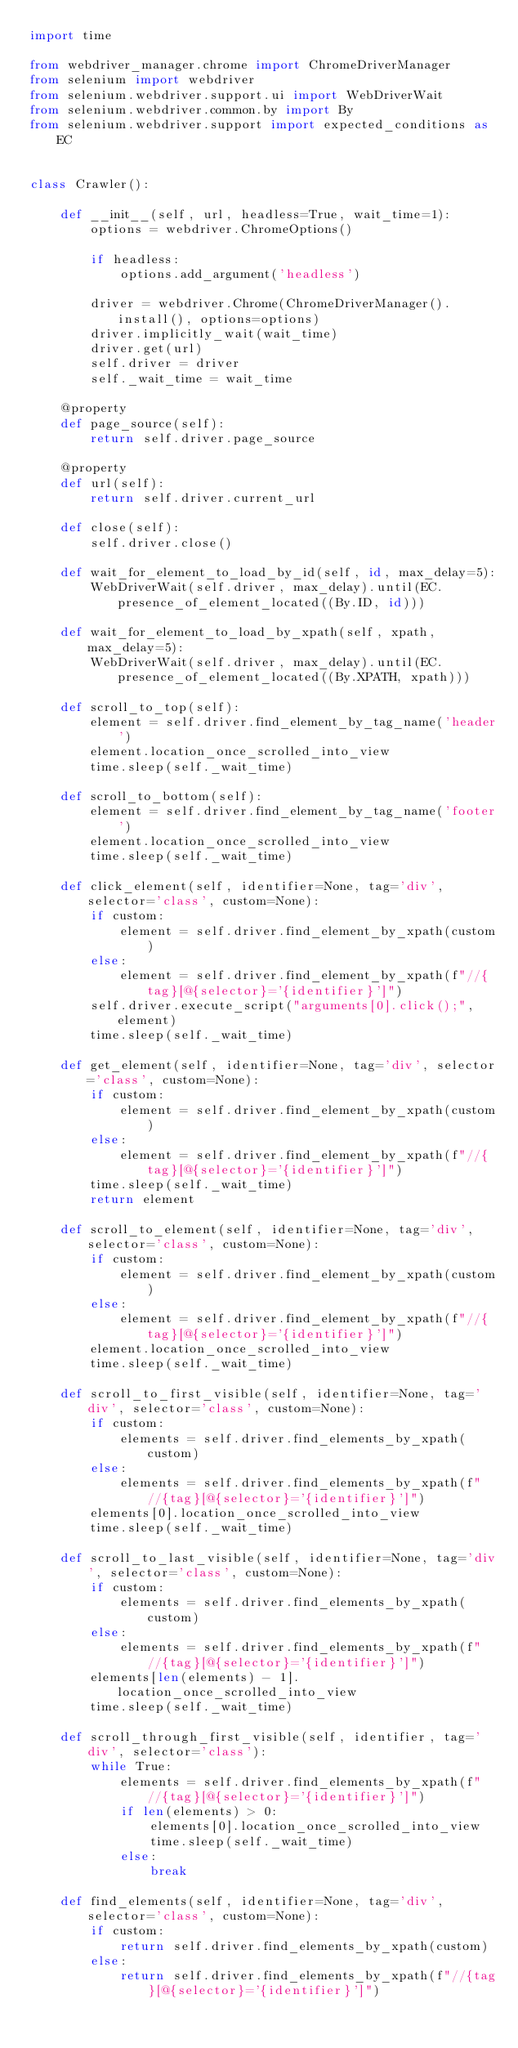Convert code to text. <code><loc_0><loc_0><loc_500><loc_500><_Python_>import time

from webdriver_manager.chrome import ChromeDriverManager
from selenium import webdriver
from selenium.webdriver.support.ui import WebDriverWait
from selenium.webdriver.common.by import By
from selenium.webdriver.support import expected_conditions as EC


class Crawler():

    def __init__(self, url, headless=True, wait_time=1):
        options = webdriver.ChromeOptions()

        if headless:
            options.add_argument('headless')

        driver = webdriver.Chrome(ChromeDriverManager().install(), options=options)
        driver.implicitly_wait(wait_time)
        driver.get(url)
        self.driver = driver
        self._wait_time = wait_time

    @property
    def page_source(self):
        return self.driver.page_source

    @property
    def url(self):
        return self.driver.current_url

    def close(self):
        self.driver.close()

    def wait_for_element_to_load_by_id(self, id, max_delay=5):
        WebDriverWait(self.driver, max_delay).until(EC.presence_of_element_located((By.ID, id)))

    def wait_for_element_to_load_by_xpath(self, xpath, max_delay=5):
        WebDriverWait(self.driver, max_delay).until(EC.presence_of_element_located((By.XPATH, xpath)))

    def scroll_to_top(self):
        element = self.driver.find_element_by_tag_name('header')
        element.location_once_scrolled_into_view
        time.sleep(self._wait_time)

    def scroll_to_bottom(self):
        element = self.driver.find_element_by_tag_name('footer')
        element.location_once_scrolled_into_view
        time.sleep(self._wait_time)

    def click_element(self, identifier=None, tag='div', selector='class', custom=None):
        if custom:
            element = self.driver.find_element_by_xpath(custom)
        else:
            element = self.driver.find_element_by_xpath(f"//{tag}[@{selector}='{identifier}']")
        self.driver.execute_script("arguments[0].click();", element)
        time.sleep(self._wait_time)

    def get_element(self, identifier=None, tag='div', selector='class', custom=None):
        if custom:
            element = self.driver.find_element_by_xpath(custom)
        else:
            element = self.driver.find_element_by_xpath(f"//{tag}[@{selector}='{identifier}']")
        time.sleep(self._wait_time)
        return element

    def scroll_to_element(self, identifier=None, tag='div', selector='class', custom=None):
        if custom:
            element = self.driver.find_element_by_xpath(custom)
        else:
            element = self.driver.find_element_by_xpath(f"//{tag}[@{selector}='{identifier}']")
        element.location_once_scrolled_into_view
        time.sleep(self._wait_time)

    def scroll_to_first_visible(self, identifier=None, tag='div', selector='class', custom=None):
        if custom:
            elements = self.driver.find_elements_by_xpath(custom)
        else:
            elements = self.driver.find_elements_by_xpath(f"//{tag}[@{selector}='{identifier}']")
        elements[0].location_once_scrolled_into_view
        time.sleep(self._wait_time)

    def scroll_to_last_visible(self, identifier=None, tag='div', selector='class', custom=None):
        if custom:
            elements = self.driver.find_elements_by_xpath(custom)
        else:
            elements = self.driver.find_elements_by_xpath(f"//{tag}[@{selector}='{identifier}']")
        elements[len(elements) - 1].location_once_scrolled_into_view
        time.sleep(self._wait_time)

    def scroll_through_first_visible(self, identifier, tag='div', selector='class'):
        while True:
            elements = self.driver.find_elements_by_xpath(f"//{tag}[@{selector}='{identifier}']")
            if len(elements) > 0:
                elements[0].location_once_scrolled_into_view
                time.sleep(self._wait_time)
            else:
                break

    def find_elements(self, identifier=None, tag='div', selector='class', custom=None):
        if custom:
            return self.driver.find_elements_by_xpath(custom)
        else:
            return self.driver.find_elements_by_xpath(f"//{tag}[@{selector}='{identifier}']")
</code> 